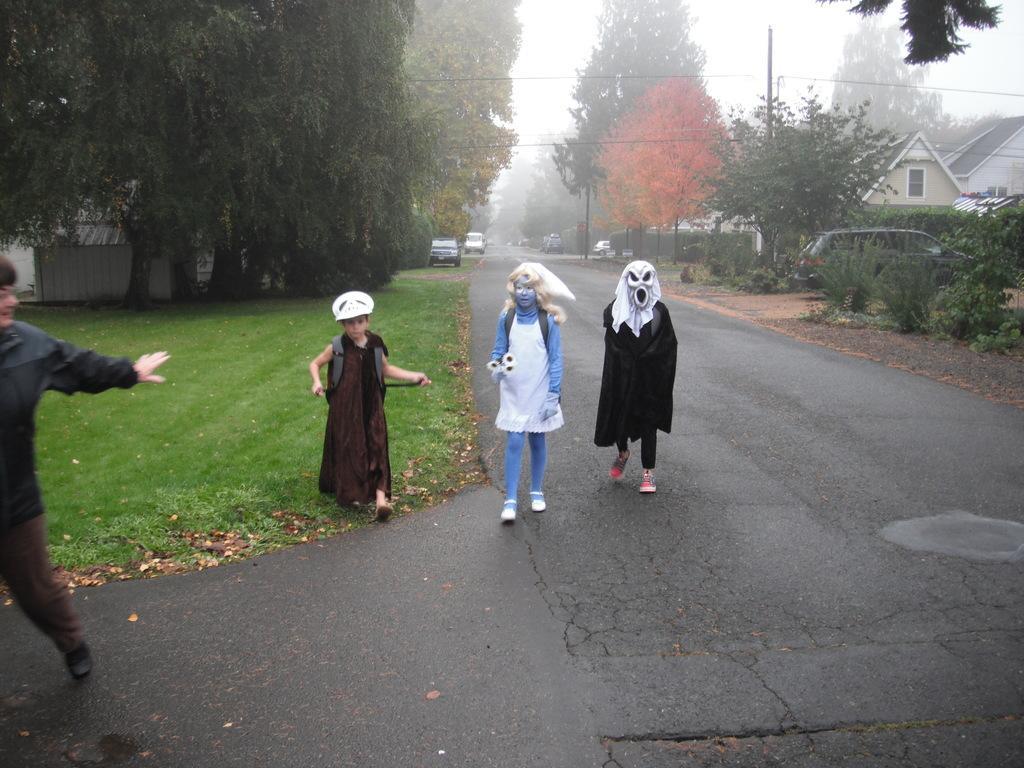Could you give a brief overview of what you see in this image? This is an outside view. Here I can see four persons are walking on the road. Two persons are wearing costumes. In the background there are some cars on the road. On the both sides of the road I can see the trees and buildings. On the left side, I can see the grass. At the top I can see the sky. 